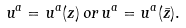Convert formula to latex. <formula><loc_0><loc_0><loc_500><loc_500>u ^ { a } = u ^ { a } ( z ) \, o r \, u ^ { a } = u ^ { a } ( \bar { z } ) .</formula> 